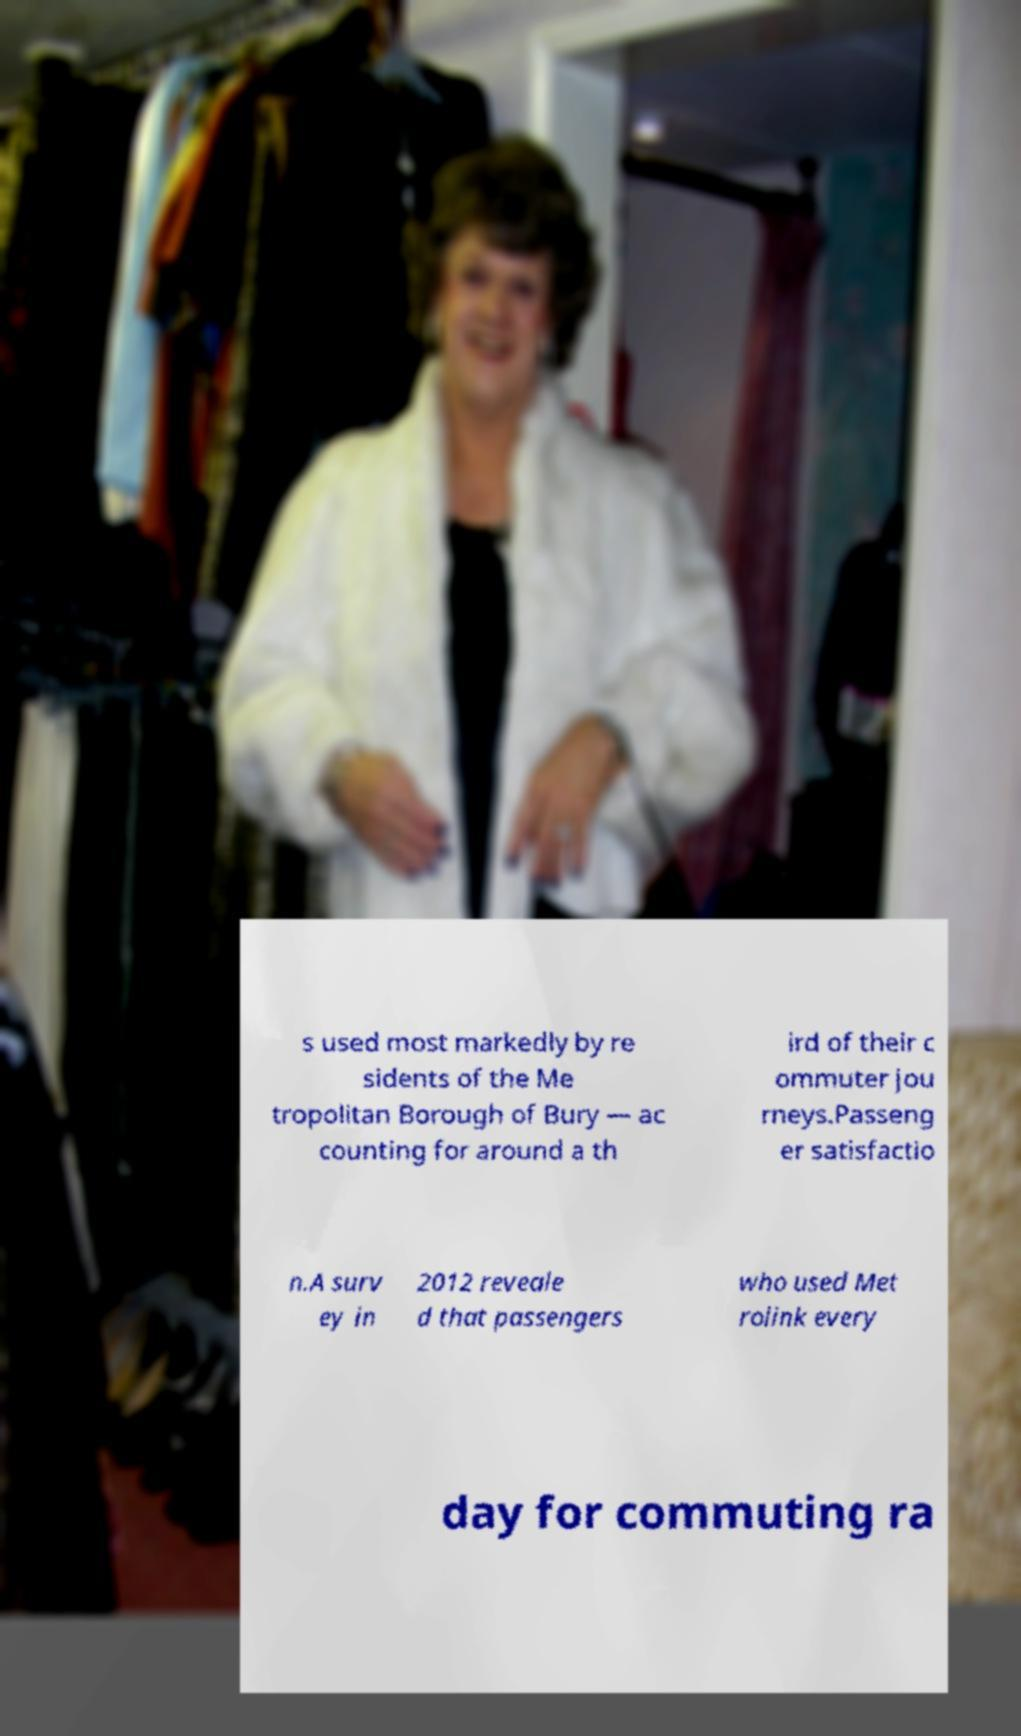Could you assist in decoding the text presented in this image and type it out clearly? s used most markedly by re sidents of the Me tropolitan Borough of Bury — ac counting for around a th ird of their c ommuter jou rneys.Passeng er satisfactio n.A surv ey in 2012 reveale d that passengers who used Met rolink every day for commuting ra 